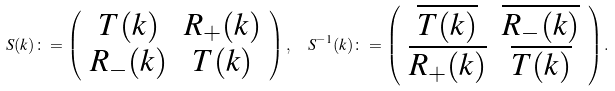<formula> <loc_0><loc_0><loc_500><loc_500>S ( k ) \colon = \left ( \begin{array} { c c } T ( k ) & R _ { + } ( k ) \\ R _ { - } ( k ) & T ( k ) \end{array} \right ) , \ \ S ^ { - 1 } ( k ) \colon = \left ( \begin{array} { c c } \overline { T ( k ) } & \overline { R _ { - } ( k ) } \\ \overline { R _ { + } ( k ) } & \overline { T ( k ) } \end{array} \right ) .</formula> 